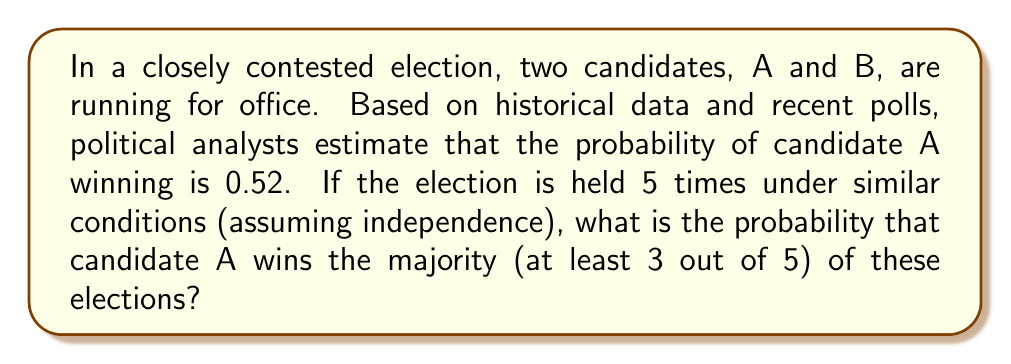Provide a solution to this math problem. To solve this problem, we can use the binomial probability distribution, which is suitable for analyzing repeated independent trials with two possible outcomes.

Let's approach this step-by-step:

1) Define the variables:
   $p$ = probability of candidate A winning a single election = 0.52
   $q$ = probability of candidate A losing a single election = 1 - p = 0.48
   $n$ = number of elections = 5
   $k$ = minimum number of wins required for majority = 3

2) We need to calculate the probability of candidate A winning 3, 4, or 5 elections out of 5.

3) The binomial probability formula for exactly $k$ successes in $n$ trials is:

   $P(X = k) = \binom{n}{k} p^k q^{n-k}$

4) We need to sum the probabilities for k = 3, 4, and 5:

   $P(\text{A wins majority}) = P(X = 3) + P(X = 4) + P(X = 5)$

5) Let's calculate each term:

   $P(X = 3) = \binom{5}{3} (0.52)^3 (0.48)^2 = 10 \cdot 0.140608 \cdot 0.2304 = 0.3240$

   $P(X = 4) = \binom{5}{4} (0.52)^4 (0.48)^1 = 5 \cdot 0.073216 \cdot 0.48 = 0.1757$

   $P(X = 5) = \binom{5}{5} (0.52)^5 (0.48)^0 = 1 \cdot 0.038088 \cdot 1 = 0.0381$

6) Sum these probabilities:

   $P(\text{A wins majority}) = 0.3240 + 0.1757 + 0.0381 = 0.5378$

Therefore, the probability that candidate A wins the majority of the 5 elections is approximately 0.5378 or 53.78%.
Answer: 0.5378 